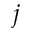<formula> <loc_0><loc_0><loc_500><loc_500>j</formula> 